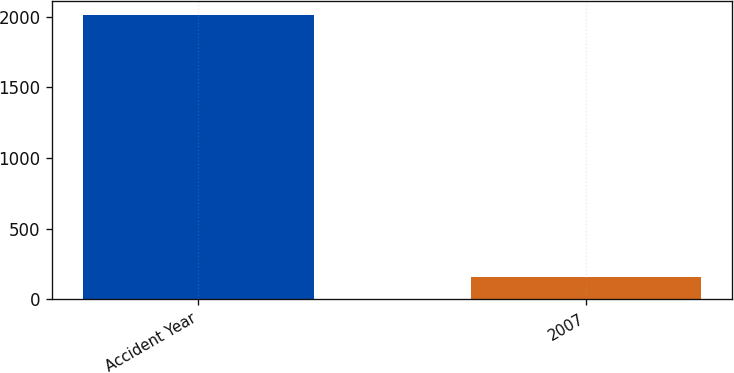<chart> <loc_0><loc_0><loc_500><loc_500><bar_chart><fcel>Accident Year<fcel>2007<nl><fcel>2009<fcel>161<nl></chart> 